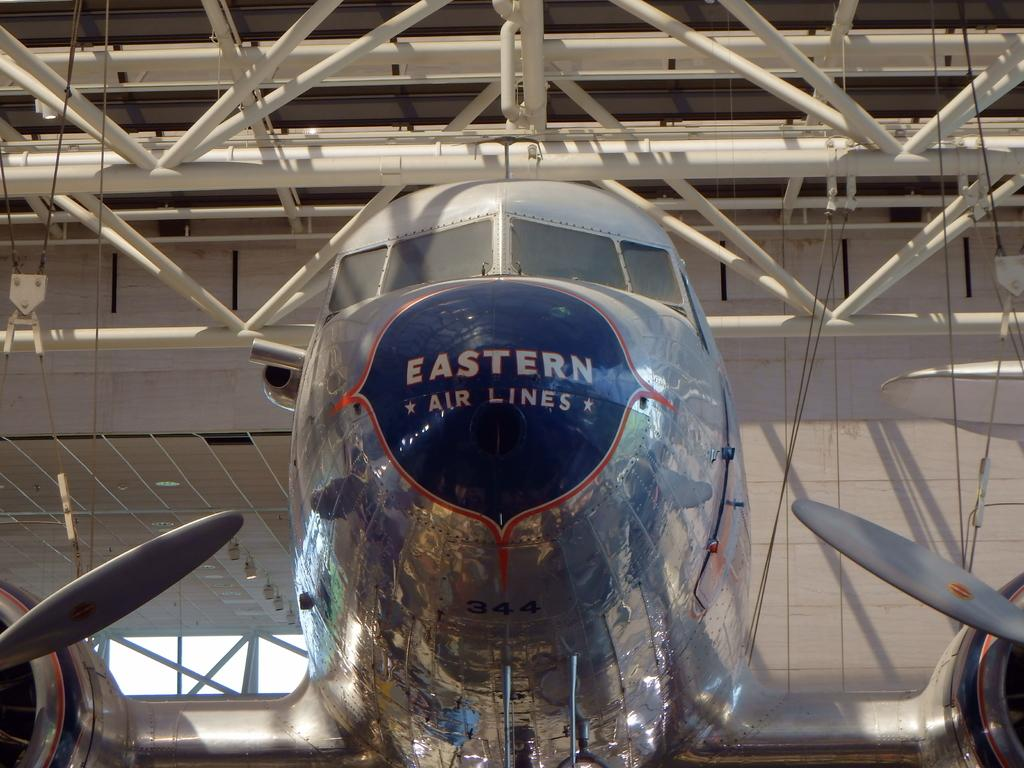<image>
Render a clear and concise summary of the photo. the front of a silver and blue eastern airlines airplane. 